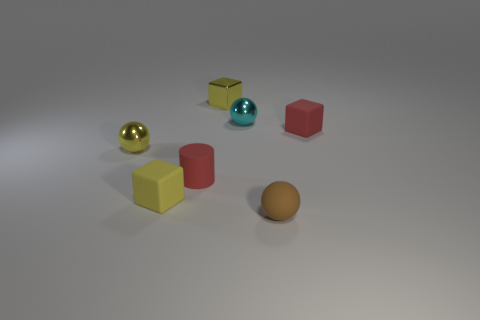Add 2 small balls. How many objects exist? 9 Subtract all cylinders. How many objects are left? 6 Add 2 shiny things. How many shiny things are left? 5 Add 7 tiny green matte cylinders. How many tiny green matte cylinders exist? 7 Subtract 0 gray cylinders. How many objects are left? 7 Subtract all small red metallic spheres. Subtract all matte cubes. How many objects are left? 5 